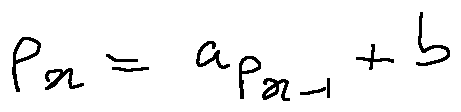<formula> <loc_0><loc_0><loc_500><loc_500>p _ { x } = a p _ { x - 1 } + b</formula> 